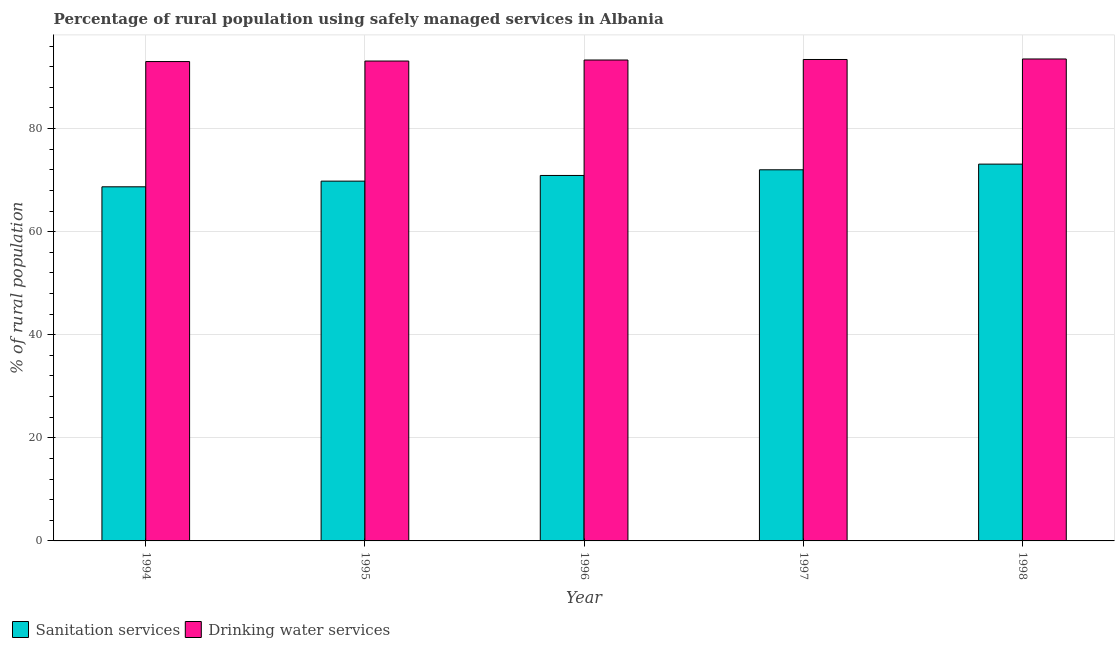How many different coloured bars are there?
Give a very brief answer. 2. How many groups of bars are there?
Make the answer very short. 5. Are the number of bars per tick equal to the number of legend labels?
Provide a succinct answer. Yes. Are the number of bars on each tick of the X-axis equal?
Make the answer very short. Yes. What is the label of the 1st group of bars from the left?
Provide a short and direct response. 1994. What is the percentage of rural population who used drinking water services in 1997?
Ensure brevity in your answer.  93.4. Across all years, what is the maximum percentage of rural population who used drinking water services?
Provide a short and direct response. 93.5. Across all years, what is the minimum percentage of rural population who used sanitation services?
Offer a terse response. 68.7. In which year was the percentage of rural population who used drinking water services maximum?
Offer a terse response. 1998. In which year was the percentage of rural population who used drinking water services minimum?
Keep it short and to the point. 1994. What is the total percentage of rural population who used sanitation services in the graph?
Offer a very short reply. 354.5. What is the difference between the percentage of rural population who used sanitation services in 1996 and that in 1997?
Keep it short and to the point. -1.1. What is the difference between the percentage of rural population who used sanitation services in 1994 and the percentage of rural population who used drinking water services in 1995?
Ensure brevity in your answer.  -1.1. What is the average percentage of rural population who used drinking water services per year?
Ensure brevity in your answer.  93.26. In the year 1996, what is the difference between the percentage of rural population who used sanitation services and percentage of rural population who used drinking water services?
Offer a very short reply. 0. In how many years, is the percentage of rural population who used sanitation services greater than 84 %?
Offer a very short reply. 0. What is the ratio of the percentage of rural population who used drinking water services in 1994 to that in 1998?
Your response must be concise. 0.99. Is the difference between the percentage of rural population who used sanitation services in 1994 and 1996 greater than the difference between the percentage of rural population who used drinking water services in 1994 and 1996?
Offer a very short reply. No. What is the difference between the highest and the second highest percentage of rural population who used sanitation services?
Offer a very short reply. 1.1. What does the 2nd bar from the left in 1997 represents?
Keep it short and to the point. Drinking water services. What does the 2nd bar from the right in 1995 represents?
Your response must be concise. Sanitation services. How many bars are there?
Make the answer very short. 10. How many years are there in the graph?
Your answer should be very brief. 5. What is the difference between two consecutive major ticks on the Y-axis?
Make the answer very short. 20. Does the graph contain grids?
Your response must be concise. Yes. Where does the legend appear in the graph?
Your answer should be very brief. Bottom left. How many legend labels are there?
Offer a very short reply. 2. What is the title of the graph?
Ensure brevity in your answer.  Percentage of rural population using safely managed services in Albania. Does "Taxes" appear as one of the legend labels in the graph?
Your response must be concise. No. What is the label or title of the X-axis?
Offer a terse response. Year. What is the label or title of the Y-axis?
Ensure brevity in your answer.  % of rural population. What is the % of rural population of Sanitation services in 1994?
Offer a very short reply. 68.7. What is the % of rural population of Drinking water services in 1994?
Provide a short and direct response. 93. What is the % of rural population in Sanitation services in 1995?
Keep it short and to the point. 69.8. What is the % of rural population of Drinking water services in 1995?
Your response must be concise. 93.1. What is the % of rural population in Sanitation services in 1996?
Your answer should be compact. 70.9. What is the % of rural population of Drinking water services in 1996?
Offer a terse response. 93.3. What is the % of rural population in Drinking water services in 1997?
Provide a short and direct response. 93.4. What is the % of rural population of Sanitation services in 1998?
Provide a short and direct response. 73.1. What is the % of rural population of Drinking water services in 1998?
Offer a very short reply. 93.5. Across all years, what is the maximum % of rural population of Sanitation services?
Ensure brevity in your answer.  73.1. Across all years, what is the maximum % of rural population in Drinking water services?
Offer a terse response. 93.5. Across all years, what is the minimum % of rural population in Sanitation services?
Ensure brevity in your answer.  68.7. Across all years, what is the minimum % of rural population in Drinking water services?
Your answer should be compact. 93. What is the total % of rural population in Sanitation services in the graph?
Offer a terse response. 354.5. What is the total % of rural population in Drinking water services in the graph?
Offer a terse response. 466.3. What is the difference between the % of rural population of Sanitation services in 1994 and that in 1995?
Your response must be concise. -1.1. What is the difference between the % of rural population in Drinking water services in 1994 and that in 1995?
Your answer should be very brief. -0.1. What is the difference between the % of rural population in Drinking water services in 1994 and that in 1997?
Offer a terse response. -0.4. What is the difference between the % of rural population in Drinking water services in 1995 and that in 1996?
Keep it short and to the point. -0.2. What is the difference between the % of rural population in Sanitation services in 1995 and that in 1997?
Offer a terse response. -2.2. What is the difference between the % of rural population of Drinking water services in 1995 and that in 1997?
Offer a terse response. -0.3. What is the difference between the % of rural population of Sanitation services in 1995 and that in 1998?
Provide a succinct answer. -3.3. What is the difference between the % of rural population in Drinking water services in 1996 and that in 1997?
Offer a terse response. -0.1. What is the difference between the % of rural population of Sanitation services in 1997 and that in 1998?
Give a very brief answer. -1.1. What is the difference between the % of rural population of Drinking water services in 1997 and that in 1998?
Give a very brief answer. -0.1. What is the difference between the % of rural population of Sanitation services in 1994 and the % of rural population of Drinking water services in 1995?
Your response must be concise. -24.4. What is the difference between the % of rural population of Sanitation services in 1994 and the % of rural population of Drinking water services in 1996?
Your answer should be very brief. -24.6. What is the difference between the % of rural population in Sanitation services in 1994 and the % of rural population in Drinking water services in 1997?
Offer a terse response. -24.7. What is the difference between the % of rural population in Sanitation services in 1994 and the % of rural population in Drinking water services in 1998?
Provide a succinct answer. -24.8. What is the difference between the % of rural population in Sanitation services in 1995 and the % of rural population in Drinking water services in 1996?
Give a very brief answer. -23.5. What is the difference between the % of rural population of Sanitation services in 1995 and the % of rural population of Drinking water services in 1997?
Your response must be concise. -23.6. What is the difference between the % of rural population of Sanitation services in 1995 and the % of rural population of Drinking water services in 1998?
Your response must be concise. -23.7. What is the difference between the % of rural population of Sanitation services in 1996 and the % of rural population of Drinking water services in 1997?
Offer a very short reply. -22.5. What is the difference between the % of rural population in Sanitation services in 1996 and the % of rural population in Drinking water services in 1998?
Your answer should be very brief. -22.6. What is the difference between the % of rural population of Sanitation services in 1997 and the % of rural population of Drinking water services in 1998?
Your answer should be compact. -21.5. What is the average % of rural population of Sanitation services per year?
Your response must be concise. 70.9. What is the average % of rural population of Drinking water services per year?
Keep it short and to the point. 93.26. In the year 1994, what is the difference between the % of rural population of Sanitation services and % of rural population of Drinking water services?
Give a very brief answer. -24.3. In the year 1995, what is the difference between the % of rural population of Sanitation services and % of rural population of Drinking water services?
Provide a short and direct response. -23.3. In the year 1996, what is the difference between the % of rural population in Sanitation services and % of rural population in Drinking water services?
Offer a very short reply. -22.4. In the year 1997, what is the difference between the % of rural population in Sanitation services and % of rural population in Drinking water services?
Offer a terse response. -21.4. In the year 1998, what is the difference between the % of rural population in Sanitation services and % of rural population in Drinking water services?
Keep it short and to the point. -20.4. What is the ratio of the % of rural population of Sanitation services in 1994 to that in 1995?
Give a very brief answer. 0.98. What is the ratio of the % of rural population of Sanitation services in 1994 to that in 1996?
Offer a very short reply. 0.97. What is the ratio of the % of rural population in Drinking water services in 1994 to that in 1996?
Your answer should be very brief. 1. What is the ratio of the % of rural population in Sanitation services in 1994 to that in 1997?
Offer a very short reply. 0.95. What is the ratio of the % of rural population in Sanitation services in 1994 to that in 1998?
Ensure brevity in your answer.  0.94. What is the ratio of the % of rural population in Drinking water services in 1994 to that in 1998?
Ensure brevity in your answer.  0.99. What is the ratio of the % of rural population in Sanitation services in 1995 to that in 1996?
Your response must be concise. 0.98. What is the ratio of the % of rural population of Drinking water services in 1995 to that in 1996?
Provide a short and direct response. 1. What is the ratio of the % of rural population of Sanitation services in 1995 to that in 1997?
Offer a very short reply. 0.97. What is the ratio of the % of rural population in Sanitation services in 1995 to that in 1998?
Your answer should be compact. 0.95. What is the ratio of the % of rural population in Sanitation services in 1996 to that in 1997?
Your answer should be compact. 0.98. What is the ratio of the % of rural population of Sanitation services in 1996 to that in 1998?
Make the answer very short. 0.97. What is the ratio of the % of rural population of Drinking water services in 1996 to that in 1998?
Your answer should be compact. 1. What is the ratio of the % of rural population in Sanitation services in 1997 to that in 1998?
Your answer should be very brief. 0.98. What is the ratio of the % of rural population in Drinking water services in 1997 to that in 1998?
Your response must be concise. 1. What is the difference between the highest and the second highest % of rural population of Sanitation services?
Offer a very short reply. 1.1. What is the difference between the highest and the second highest % of rural population of Drinking water services?
Offer a terse response. 0.1. What is the difference between the highest and the lowest % of rural population in Sanitation services?
Offer a terse response. 4.4. What is the difference between the highest and the lowest % of rural population in Drinking water services?
Your response must be concise. 0.5. 